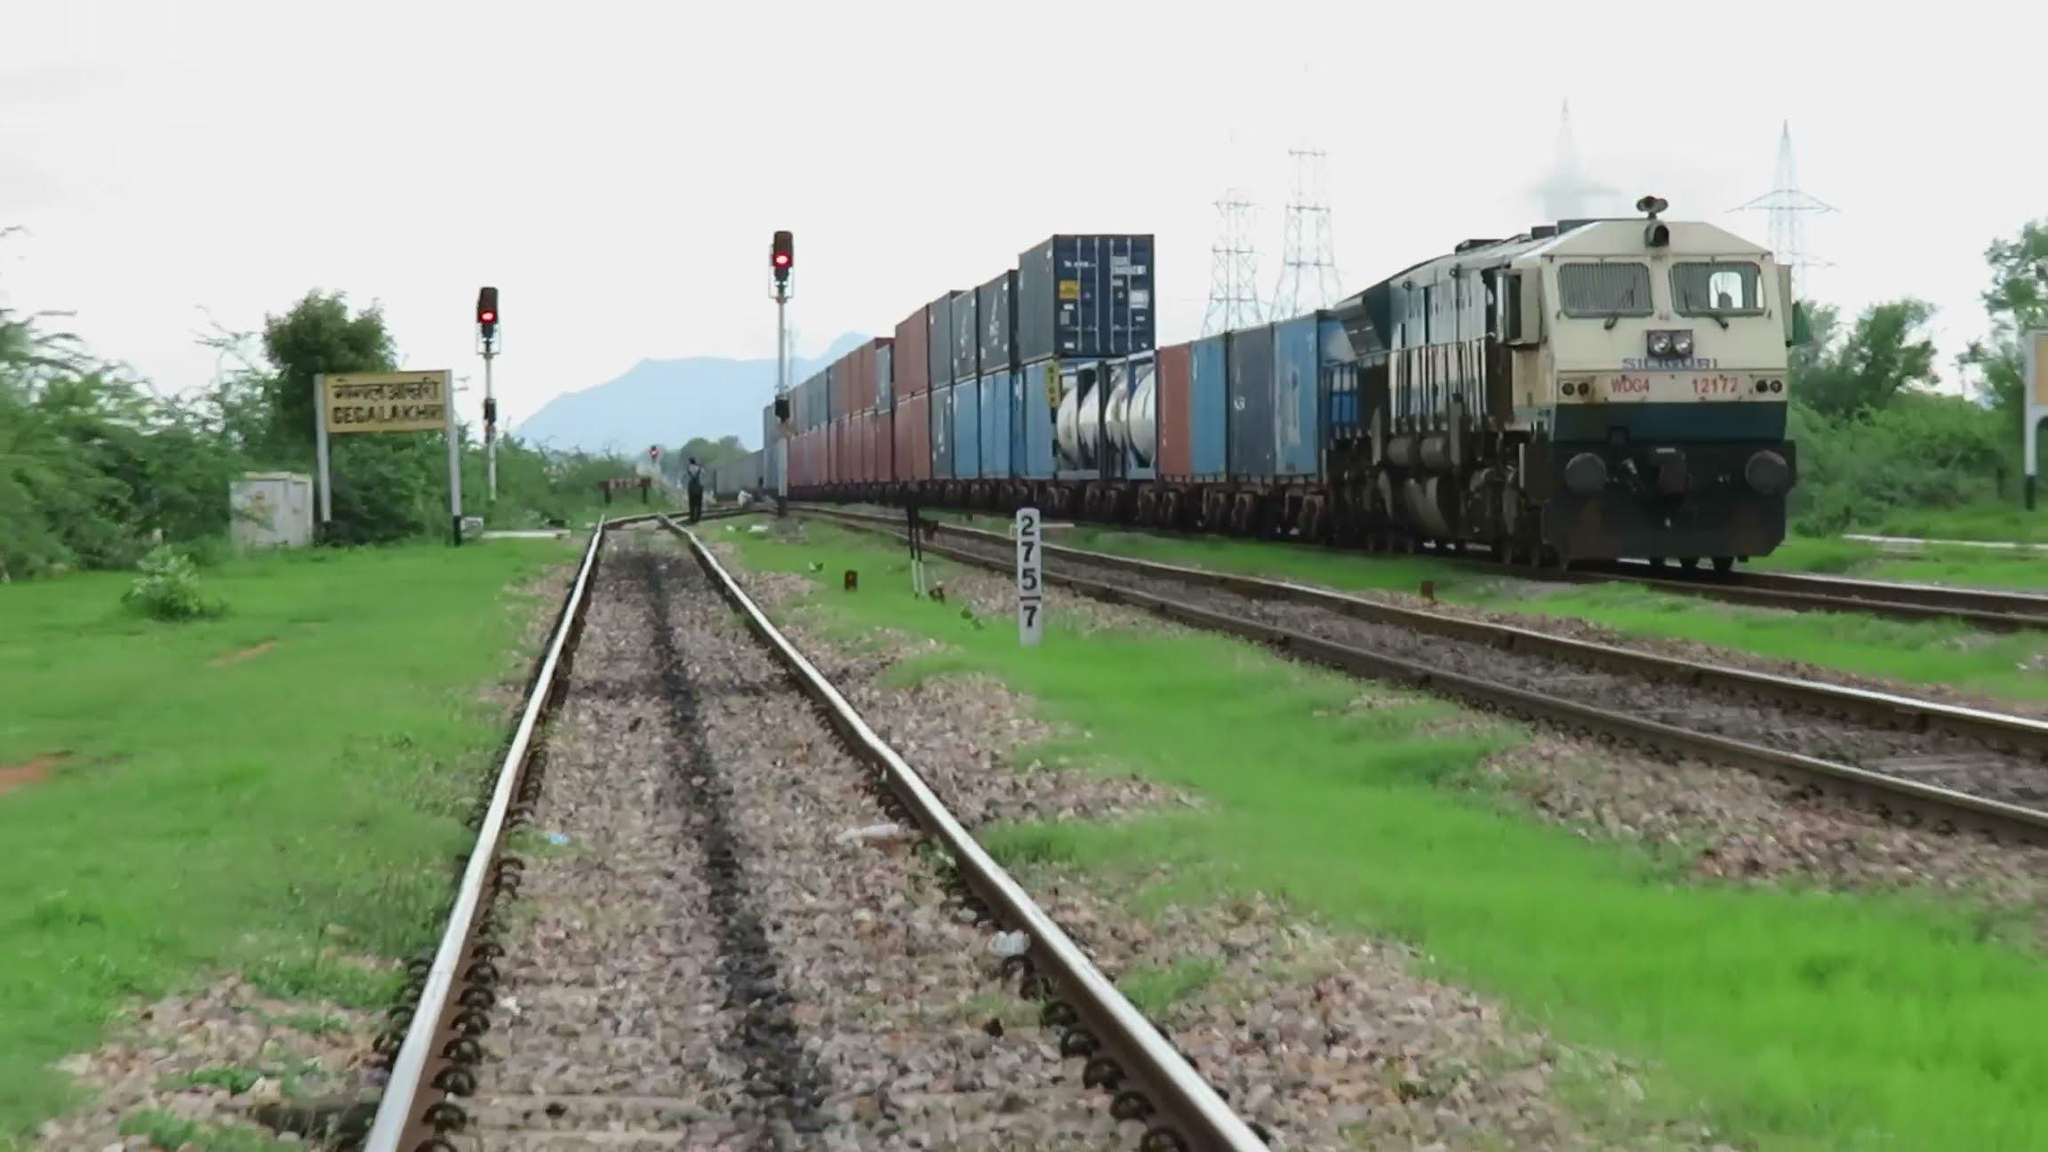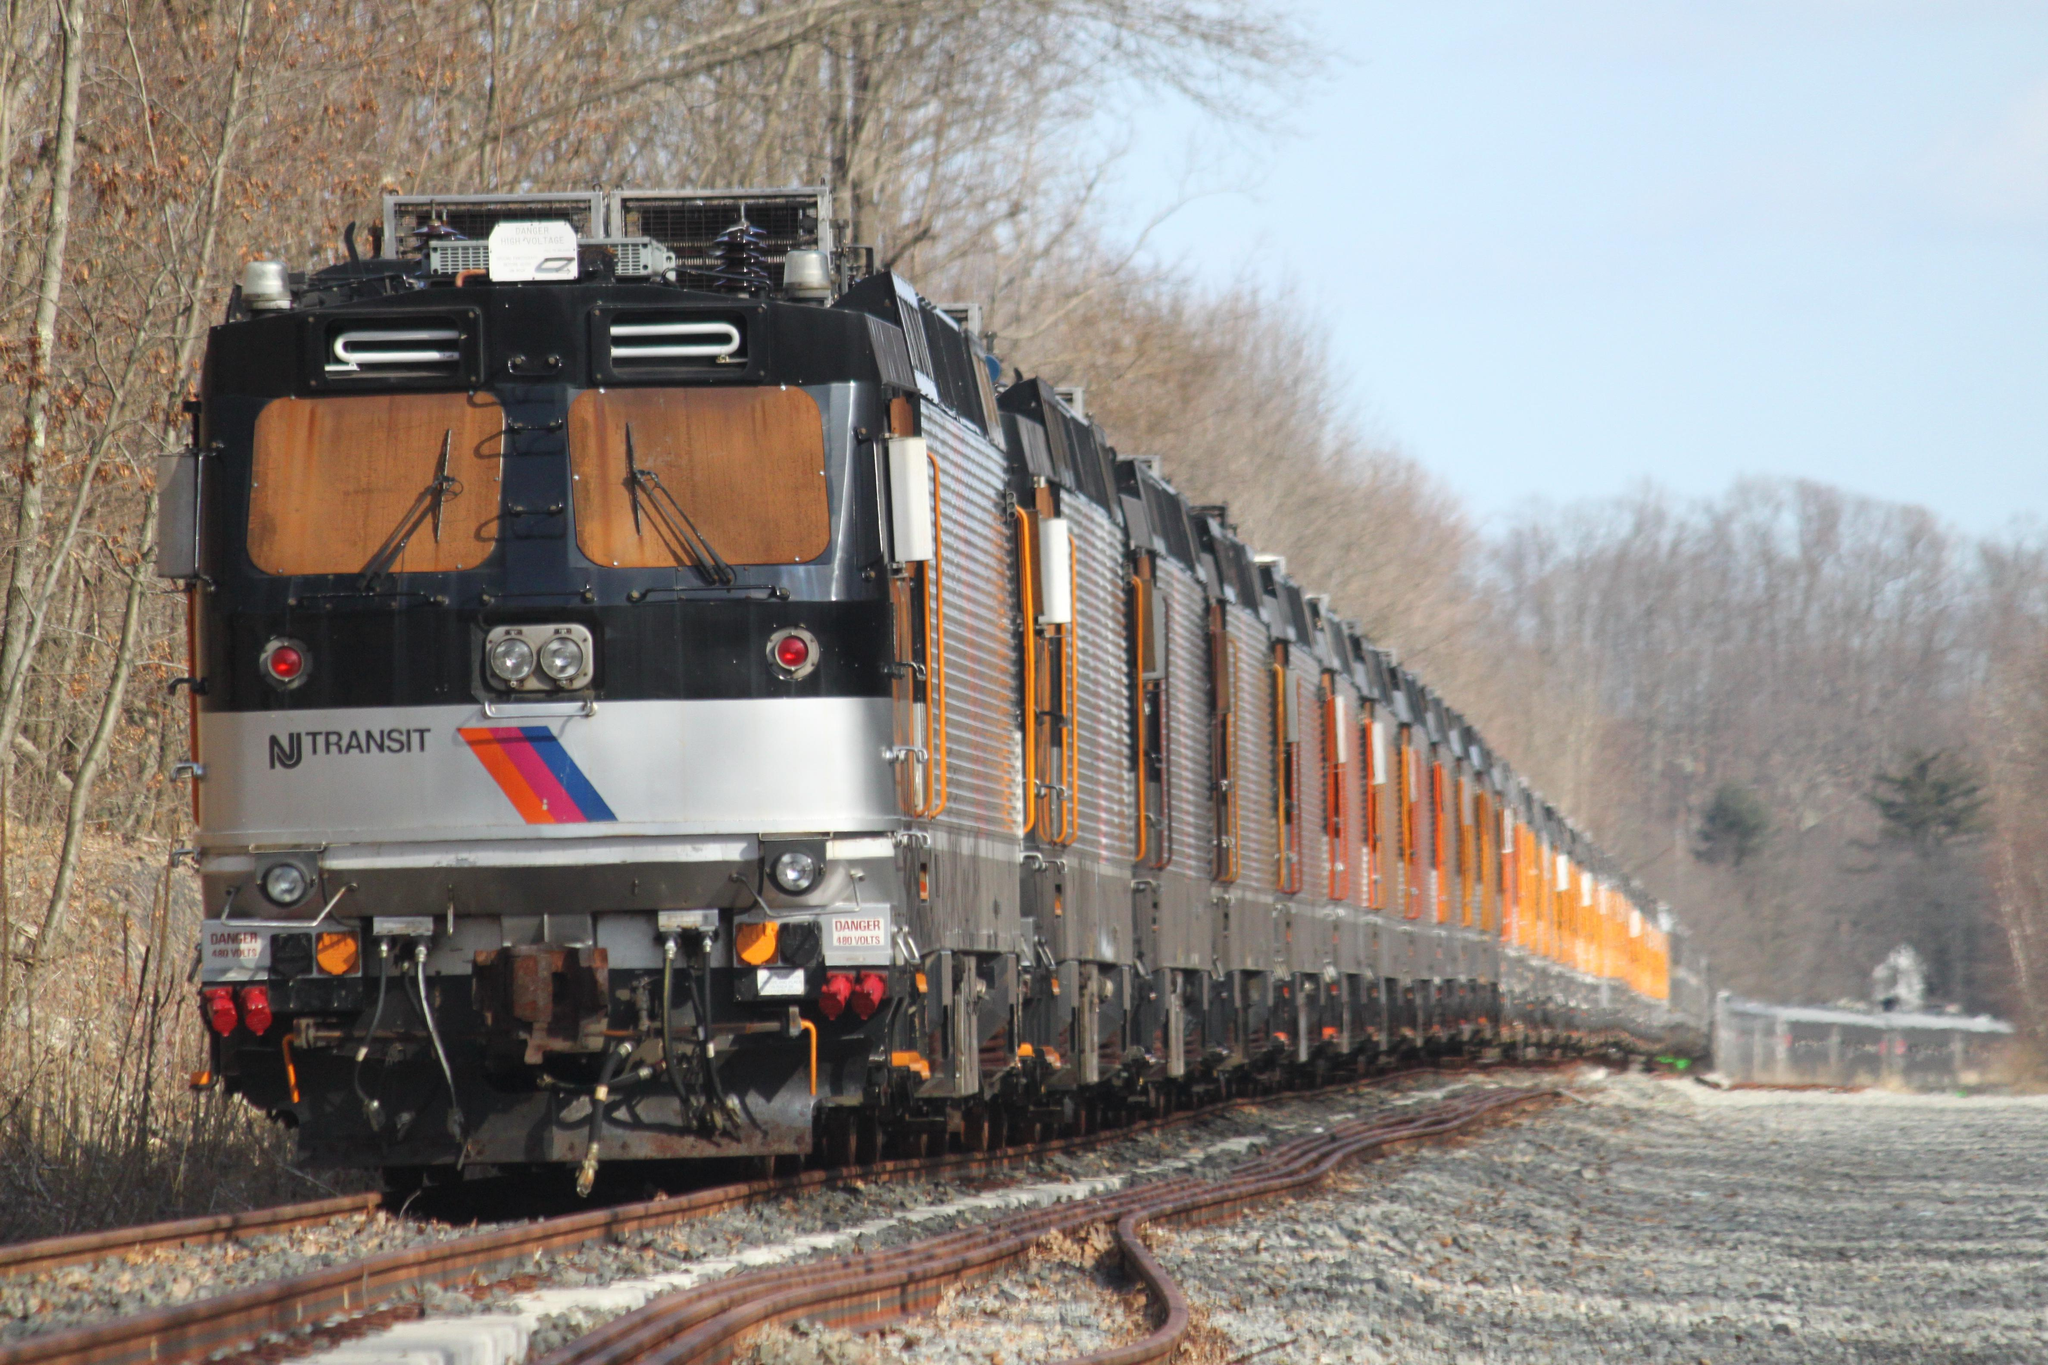The first image is the image on the left, the second image is the image on the right. Given the left and right images, does the statement "A predominantly yellow train is traveling slightly towards the right." hold true? Answer yes or no. No. The first image is the image on the left, the second image is the image on the right. Assess this claim about the two images: "An image shows a train going under a structure that spans the tracks with a zig-zag structural element.". Correct or not? Answer yes or no. No. 